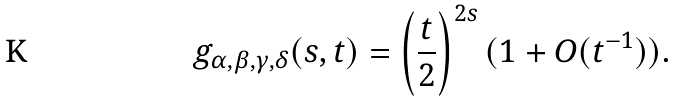Convert formula to latex. <formula><loc_0><loc_0><loc_500><loc_500>g _ { \alpha , \beta , \gamma , \delta } ( s , t ) = \left ( \frac { t } { 2 } \right ) ^ { 2 s } ( 1 + O ( t ^ { - 1 } ) ) .</formula> 